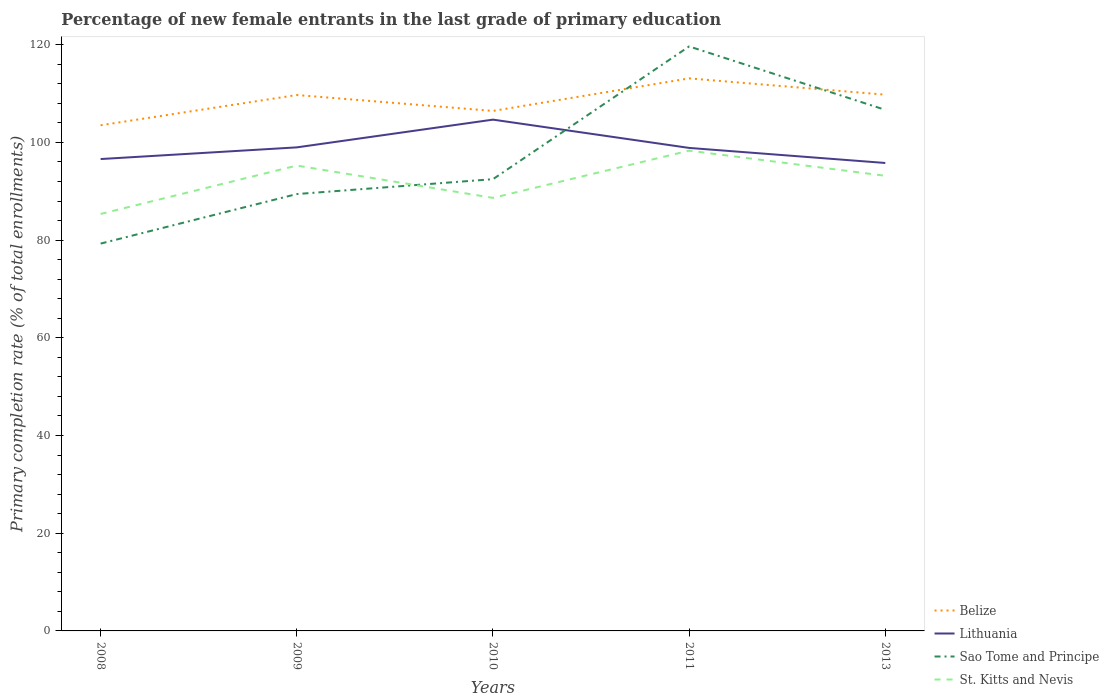How many different coloured lines are there?
Ensure brevity in your answer.  4. Does the line corresponding to Belize intersect with the line corresponding to St. Kitts and Nevis?
Provide a short and direct response. No. Across all years, what is the maximum percentage of new female entrants in Sao Tome and Principe?
Your answer should be very brief. 79.3. In which year was the percentage of new female entrants in Lithuania maximum?
Provide a short and direct response. 2013. What is the total percentage of new female entrants in Lithuania in the graph?
Your answer should be very brief. -2.39. What is the difference between the highest and the second highest percentage of new female entrants in Belize?
Your answer should be compact. 9.6. Is the percentage of new female entrants in Lithuania strictly greater than the percentage of new female entrants in Sao Tome and Principe over the years?
Your answer should be compact. No. How many lines are there?
Give a very brief answer. 4. What is the difference between two consecutive major ticks on the Y-axis?
Keep it short and to the point. 20. Are the values on the major ticks of Y-axis written in scientific E-notation?
Ensure brevity in your answer.  No. Does the graph contain any zero values?
Keep it short and to the point. No. Does the graph contain grids?
Ensure brevity in your answer.  No. Where does the legend appear in the graph?
Offer a terse response. Bottom right. How are the legend labels stacked?
Ensure brevity in your answer.  Vertical. What is the title of the graph?
Provide a succinct answer. Percentage of new female entrants in the last grade of primary education. What is the label or title of the X-axis?
Provide a short and direct response. Years. What is the label or title of the Y-axis?
Your answer should be very brief. Primary completion rate (% of total enrollments). What is the Primary completion rate (% of total enrollments) in Belize in 2008?
Offer a very short reply. 103.52. What is the Primary completion rate (% of total enrollments) of Lithuania in 2008?
Your answer should be very brief. 96.6. What is the Primary completion rate (% of total enrollments) of Sao Tome and Principe in 2008?
Make the answer very short. 79.3. What is the Primary completion rate (% of total enrollments) of St. Kitts and Nevis in 2008?
Offer a very short reply. 85.37. What is the Primary completion rate (% of total enrollments) in Belize in 2009?
Offer a terse response. 109.71. What is the Primary completion rate (% of total enrollments) of Lithuania in 2009?
Make the answer very short. 98.99. What is the Primary completion rate (% of total enrollments) of Sao Tome and Principe in 2009?
Your response must be concise. 89.44. What is the Primary completion rate (% of total enrollments) in St. Kitts and Nevis in 2009?
Offer a terse response. 95.27. What is the Primary completion rate (% of total enrollments) in Belize in 2010?
Provide a short and direct response. 106.45. What is the Primary completion rate (% of total enrollments) of Lithuania in 2010?
Your response must be concise. 104.67. What is the Primary completion rate (% of total enrollments) of Sao Tome and Principe in 2010?
Keep it short and to the point. 92.48. What is the Primary completion rate (% of total enrollments) of St. Kitts and Nevis in 2010?
Your answer should be very brief. 88.66. What is the Primary completion rate (% of total enrollments) of Belize in 2011?
Keep it short and to the point. 113.12. What is the Primary completion rate (% of total enrollments) in Lithuania in 2011?
Make the answer very short. 98.88. What is the Primary completion rate (% of total enrollments) in Sao Tome and Principe in 2011?
Give a very brief answer. 119.66. What is the Primary completion rate (% of total enrollments) of St. Kitts and Nevis in 2011?
Your response must be concise. 98.32. What is the Primary completion rate (% of total enrollments) of Belize in 2013?
Offer a very short reply. 109.78. What is the Primary completion rate (% of total enrollments) in Lithuania in 2013?
Your answer should be compact. 95.8. What is the Primary completion rate (% of total enrollments) in Sao Tome and Principe in 2013?
Keep it short and to the point. 106.68. What is the Primary completion rate (% of total enrollments) of St. Kitts and Nevis in 2013?
Offer a very short reply. 93.18. Across all years, what is the maximum Primary completion rate (% of total enrollments) of Belize?
Offer a terse response. 113.12. Across all years, what is the maximum Primary completion rate (% of total enrollments) in Lithuania?
Ensure brevity in your answer.  104.67. Across all years, what is the maximum Primary completion rate (% of total enrollments) of Sao Tome and Principe?
Ensure brevity in your answer.  119.66. Across all years, what is the maximum Primary completion rate (% of total enrollments) in St. Kitts and Nevis?
Your answer should be very brief. 98.32. Across all years, what is the minimum Primary completion rate (% of total enrollments) of Belize?
Keep it short and to the point. 103.52. Across all years, what is the minimum Primary completion rate (% of total enrollments) in Lithuania?
Make the answer very short. 95.8. Across all years, what is the minimum Primary completion rate (% of total enrollments) of Sao Tome and Principe?
Your answer should be compact. 79.3. Across all years, what is the minimum Primary completion rate (% of total enrollments) in St. Kitts and Nevis?
Your answer should be compact. 85.37. What is the total Primary completion rate (% of total enrollments) in Belize in the graph?
Make the answer very short. 542.58. What is the total Primary completion rate (% of total enrollments) in Lithuania in the graph?
Your answer should be compact. 494.95. What is the total Primary completion rate (% of total enrollments) in Sao Tome and Principe in the graph?
Keep it short and to the point. 487.55. What is the total Primary completion rate (% of total enrollments) of St. Kitts and Nevis in the graph?
Offer a terse response. 460.79. What is the difference between the Primary completion rate (% of total enrollments) in Belize in 2008 and that in 2009?
Offer a terse response. -6.19. What is the difference between the Primary completion rate (% of total enrollments) of Lithuania in 2008 and that in 2009?
Your response must be concise. -2.39. What is the difference between the Primary completion rate (% of total enrollments) of Sao Tome and Principe in 2008 and that in 2009?
Keep it short and to the point. -10.14. What is the difference between the Primary completion rate (% of total enrollments) in St. Kitts and Nevis in 2008 and that in 2009?
Give a very brief answer. -9.9. What is the difference between the Primary completion rate (% of total enrollments) of Belize in 2008 and that in 2010?
Offer a very short reply. -2.93. What is the difference between the Primary completion rate (% of total enrollments) in Lithuania in 2008 and that in 2010?
Make the answer very short. -8.07. What is the difference between the Primary completion rate (% of total enrollments) of Sao Tome and Principe in 2008 and that in 2010?
Provide a short and direct response. -13.19. What is the difference between the Primary completion rate (% of total enrollments) of St. Kitts and Nevis in 2008 and that in 2010?
Provide a short and direct response. -3.29. What is the difference between the Primary completion rate (% of total enrollments) in Belize in 2008 and that in 2011?
Keep it short and to the point. -9.6. What is the difference between the Primary completion rate (% of total enrollments) in Lithuania in 2008 and that in 2011?
Ensure brevity in your answer.  -2.28. What is the difference between the Primary completion rate (% of total enrollments) in Sao Tome and Principe in 2008 and that in 2011?
Your response must be concise. -40.36. What is the difference between the Primary completion rate (% of total enrollments) of St. Kitts and Nevis in 2008 and that in 2011?
Keep it short and to the point. -12.96. What is the difference between the Primary completion rate (% of total enrollments) in Belize in 2008 and that in 2013?
Ensure brevity in your answer.  -6.26. What is the difference between the Primary completion rate (% of total enrollments) of Lithuania in 2008 and that in 2013?
Your answer should be compact. 0.8. What is the difference between the Primary completion rate (% of total enrollments) of Sao Tome and Principe in 2008 and that in 2013?
Make the answer very short. -27.38. What is the difference between the Primary completion rate (% of total enrollments) of St. Kitts and Nevis in 2008 and that in 2013?
Make the answer very short. -7.81. What is the difference between the Primary completion rate (% of total enrollments) in Belize in 2009 and that in 2010?
Ensure brevity in your answer.  3.26. What is the difference between the Primary completion rate (% of total enrollments) of Lithuania in 2009 and that in 2010?
Your answer should be compact. -5.68. What is the difference between the Primary completion rate (% of total enrollments) in Sao Tome and Principe in 2009 and that in 2010?
Your response must be concise. -3.05. What is the difference between the Primary completion rate (% of total enrollments) of St. Kitts and Nevis in 2009 and that in 2010?
Offer a terse response. 6.61. What is the difference between the Primary completion rate (% of total enrollments) in Belize in 2009 and that in 2011?
Make the answer very short. -3.4. What is the difference between the Primary completion rate (% of total enrollments) in Lithuania in 2009 and that in 2011?
Provide a short and direct response. 0.11. What is the difference between the Primary completion rate (% of total enrollments) of Sao Tome and Principe in 2009 and that in 2011?
Your answer should be very brief. -30.22. What is the difference between the Primary completion rate (% of total enrollments) in St. Kitts and Nevis in 2009 and that in 2011?
Your answer should be very brief. -3.05. What is the difference between the Primary completion rate (% of total enrollments) of Belize in 2009 and that in 2013?
Your response must be concise. -0.07. What is the difference between the Primary completion rate (% of total enrollments) in Lithuania in 2009 and that in 2013?
Provide a short and direct response. 3.2. What is the difference between the Primary completion rate (% of total enrollments) in Sao Tome and Principe in 2009 and that in 2013?
Make the answer very short. -17.24. What is the difference between the Primary completion rate (% of total enrollments) in St. Kitts and Nevis in 2009 and that in 2013?
Offer a very short reply. 2.09. What is the difference between the Primary completion rate (% of total enrollments) of Belize in 2010 and that in 2011?
Your response must be concise. -6.66. What is the difference between the Primary completion rate (% of total enrollments) of Lithuania in 2010 and that in 2011?
Keep it short and to the point. 5.79. What is the difference between the Primary completion rate (% of total enrollments) in Sao Tome and Principe in 2010 and that in 2011?
Offer a terse response. -27.18. What is the difference between the Primary completion rate (% of total enrollments) of St. Kitts and Nevis in 2010 and that in 2011?
Provide a short and direct response. -9.67. What is the difference between the Primary completion rate (% of total enrollments) of Belize in 2010 and that in 2013?
Your answer should be very brief. -3.33. What is the difference between the Primary completion rate (% of total enrollments) in Lithuania in 2010 and that in 2013?
Ensure brevity in your answer.  8.87. What is the difference between the Primary completion rate (% of total enrollments) in Sao Tome and Principe in 2010 and that in 2013?
Ensure brevity in your answer.  -14.19. What is the difference between the Primary completion rate (% of total enrollments) in St. Kitts and Nevis in 2010 and that in 2013?
Offer a very short reply. -4.52. What is the difference between the Primary completion rate (% of total enrollments) of Belize in 2011 and that in 2013?
Offer a very short reply. 3.34. What is the difference between the Primary completion rate (% of total enrollments) in Lithuania in 2011 and that in 2013?
Offer a very short reply. 3.08. What is the difference between the Primary completion rate (% of total enrollments) in Sao Tome and Principe in 2011 and that in 2013?
Keep it short and to the point. 12.98. What is the difference between the Primary completion rate (% of total enrollments) of St. Kitts and Nevis in 2011 and that in 2013?
Ensure brevity in your answer.  5.15. What is the difference between the Primary completion rate (% of total enrollments) of Belize in 2008 and the Primary completion rate (% of total enrollments) of Lithuania in 2009?
Make the answer very short. 4.53. What is the difference between the Primary completion rate (% of total enrollments) in Belize in 2008 and the Primary completion rate (% of total enrollments) in Sao Tome and Principe in 2009?
Provide a short and direct response. 14.09. What is the difference between the Primary completion rate (% of total enrollments) in Belize in 2008 and the Primary completion rate (% of total enrollments) in St. Kitts and Nevis in 2009?
Your answer should be very brief. 8.25. What is the difference between the Primary completion rate (% of total enrollments) of Lithuania in 2008 and the Primary completion rate (% of total enrollments) of Sao Tome and Principe in 2009?
Provide a short and direct response. 7.17. What is the difference between the Primary completion rate (% of total enrollments) in Lithuania in 2008 and the Primary completion rate (% of total enrollments) in St. Kitts and Nevis in 2009?
Keep it short and to the point. 1.33. What is the difference between the Primary completion rate (% of total enrollments) of Sao Tome and Principe in 2008 and the Primary completion rate (% of total enrollments) of St. Kitts and Nevis in 2009?
Your response must be concise. -15.97. What is the difference between the Primary completion rate (% of total enrollments) of Belize in 2008 and the Primary completion rate (% of total enrollments) of Lithuania in 2010?
Offer a terse response. -1.15. What is the difference between the Primary completion rate (% of total enrollments) of Belize in 2008 and the Primary completion rate (% of total enrollments) of Sao Tome and Principe in 2010?
Your answer should be very brief. 11.04. What is the difference between the Primary completion rate (% of total enrollments) of Belize in 2008 and the Primary completion rate (% of total enrollments) of St. Kitts and Nevis in 2010?
Your answer should be compact. 14.87. What is the difference between the Primary completion rate (% of total enrollments) of Lithuania in 2008 and the Primary completion rate (% of total enrollments) of Sao Tome and Principe in 2010?
Offer a terse response. 4.12. What is the difference between the Primary completion rate (% of total enrollments) in Lithuania in 2008 and the Primary completion rate (% of total enrollments) in St. Kitts and Nevis in 2010?
Offer a very short reply. 7.95. What is the difference between the Primary completion rate (% of total enrollments) in Sao Tome and Principe in 2008 and the Primary completion rate (% of total enrollments) in St. Kitts and Nevis in 2010?
Ensure brevity in your answer.  -9.36. What is the difference between the Primary completion rate (% of total enrollments) of Belize in 2008 and the Primary completion rate (% of total enrollments) of Lithuania in 2011?
Keep it short and to the point. 4.64. What is the difference between the Primary completion rate (% of total enrollments) in Belize in 2008 and the Primary completion rate (% of total enrollments) in Sao Tome and Principe in 2011?
Provide a succinct answer. -16.14. What is the difference between the Primary completion rate (% of total enrollments) in Belize in 2008 and the Primary completion rate (% of total enrollments) in St. Kitts and Nevis in 2011?
Offer a terse response. 5.2. What is the difference between the Primary completion rate (% of total enrollments) in Lithuania in 2008 and the Primary completion rate (% of total enrollments) in Sao Tome and Principe in 2011?
Give a very brief answer. -23.05. What is the difference between the Primary completion rate (% of total enrollments) of Lithuania in 2008 and the Primary completion rate (% of total enrollments) of St. Kitts and Nevis in 2011?
Your answer should be compact. -1.72. What is the difference between the Primary completion rate (% of total enrollments) in Sao Tome and Principe in 2008 and the Primary completion rate (% of total enrollments) in St. Kitts and Nevis in 2011?
Provide a succinct answer. -19.03. What is the difference between the Primary completion rate (% of total enrollments) in Belize in 2008 and the Primary completion rate (% of total enrollments) in Lithuania in 2013?
Your answer should be very brief. 7.72. What is the difference between the Primary completion rate (% of total enrollments) of Belize in 2008 and the Primary completion rate (% of total enrollments) of Sao Tome and Principe in 2013?
Provide a short and direct response. -3.15. What is the difference between the Primary completion rate (% of total enrollments) of Belize in 2008 and the Primary completion rate (% of total enrollments) of St. Kitts and Nevis in 2013?
Your answer should be compact. 10.34. What is the difference between the Primary completion rate (% of total enrollments) of Lithuania in 2008 and the Primary completion rate (% of total enrollments) of Sao Tome and Principe in 2013?
Your response must be concise. -10.07. What is the difference between the Primary completion rate (% of total enrollments) of Lithuania in 2008 and the Primary completion rate (% of total enrollments) of St. Kitts and Nevis in 2013?
Keep it short and to the point. 3.43. What is the difference between the Primary completion rate (% of total enrollments) in Sao Tome and Principe in 2008 and the Primary completion rate (% of total enrollments) in St. Kitts and Nevis in 2013?
Keep it short and to the point. -13.88. What is the difference between the Primary completion rate (% of total enrollments) in Belize in 2009 and the Primary completion rate (% of total enrollments) in Lithuania in 2010?
Make the answer very short. 5.04. What is the difference between the Primary completion rate (% of total enrollments) in Belize in 2009 and the Primary completion rate (% of total enrollments) in Sao Tome and Principe in 2010?
Provide a succinct answer. 17.23. What is the difference between the Primary completion rate (% of total enrollments) in Belize in 2009 and the Primary completion rate (% of total enrollments) in St. Kitts and Nevis in 2010?
Provide a short and direct response. 21.06. What is the difference between the Primary completion rate (% of total enrollments) of Lithuania in 2009 and the Primary completion rate (% of total enrollments) of Sao Tome and Principe in 2010?
Your answer should be very brief. 6.51. What is the difference between the Primary completion rate (% of total enrollments) in Lithuania in 2009 and the Primary completion rate (% of total enrollments) in St. Kitts and Nevis in 2010?
Your response must be concise. 10.34. What is the difference between the Primary completion rate (% of total enrollments) of Sao Tome and Principe in 2009 and the Primary completion rate (% of total enrollments) of St. Kitts and Nevis in 2010?
Your answer should be compact. 0.78. What is the difference between the Primary completion rate (% of total enrollments) of Belize in 2009 and the Primary completion rate (% of total enrollments) of Lithuania in 2011?
Your answer should be very brief. 10.83. What is the difference between the Primary completion rate (% of total enrollments) in Belize in 2009 and the Primary completion rate (% of total enrollments) in Sao Tome and Principe in 2011?
Your answer should be compact. -9.94. What is the difference between the Primary completion rate (% of total enrollments) of Belize in 2009 and the Primary completion rate (% of total enrollments) of St. Kitts and Nevis in 2011?
Give a very brief answer. 11.39. What is the difference between the Primary completion rate (% of total enrollments) in Lithuania in 2009 and the Primary completion rate (% of total enrollments) in Sao Tome and Principe in 2011?
Your answer should be very brief. -20.66. What is the difference between the Primary completion rate (% of total enrollments) of Lithuania in 2009 and the Primary completion rate (% of total enrollments) of St. Kitts and Nevis in 2011?
Your answer should be very brief. 0.67. What is the difference between the Primary completion rate (% of total enrollments) in Sao Tome and Principe in 2009 and the Primary completion rate (% of total enrollments) in St. Kitts and Nevis in 2011?
Offer a terse response. -8.89. What is the difference between the Primary completion rate (% of total enrollments) of Belize in 2009 and the Primary completion rate (% of total enrollments) of Lithuania in 2013?
Keep it short and to the point. 13.91. What is the difference between the Primary completion rate (% of total enrollments) in Belize in 2009 and the Primary completion rate (% of total enrollments) in Sao Tome and Principe in 2013?
Provide a short and direct response. 3.04. What is the difference between the Primary completion rate (% of total enrollments) of Belize in 2009 and the Primary completion rate (% of total enrollments) of St. Kitts and Nevis in 2013?
Keep it short and to the point. 16.54. What is the difference between the Primary completion rate (% of total enrollments) in Lithuania in 2009 and the Primary completion rate (% of total enrollments) in Sao Tome and Principe in 2013?
Offer a very short reply. -7.68. What is the difference between the Primary completion rate (% of total enrollments) of Lithuania in 2009 and the Primary completion rate (% of total enrollments) of St. Kitts and Nevis in 2013?
Provide a succinct answer. 5.82. What is the difference between the Primary completion rate (% of total enrollments) of Sao Tome and Principe in 2009 and the Primary completion rate (% of total enrollments) of St. Kitts and Nevis in 2013?
Offer a terse response. -3.74. What is the difference between the Primary completion rate (% of total enrollments) of Belize in 2010 and the Primary completion rate (% of total enrollments) of Lithuania in 2011?
Give a very brief answer. 7.57. What is the difference between the Primary completion rate (% of total enrollments) of Belize in 2010 and the Primary completion rate (% of total enrollments) of Sao Tome and Principe in 2011?
Make the answer very short. -13.2. What is the difference between the Primary completion rate (% of total enrollments) in Belize in 2010 and the Primary completion rate (% of total enrollments) in St. Kitts and Nevis in 2011?
Provide a short and direct response. 8.13. What is the difference between the Primary completion rate (% of total enrollments) in Lithuania in 2010 and the Primary completion rate (% of total enrollments) in Sao Tome and Principe in 2011?
Offer a very short reply. -14.98. What is the difference between the Primary completion rate (% of total enrollments) of Lithuania in 2010 and the Primary completion rate (% of total enrollments) of St. Kitts and Nevis in 2011?
Ensure brevity in your answer.  6.35. What is the difference between the Primary completion rate (% of total enrollments) of Sao Tome and Principe in 2010 and the Primary completion rate (% of total enrollments) of St. Kitts and Nevis in 2011?
Ensure brevity in your answer.  -5.84. What is the difference between the Primary completion rate (% of total enrollments) in Belize in 2010 and the Primary completion rate (% of total enrollments) in Lithuania in 2013?
Keep it short and to the point. 10.65. What is the difference between the Primary completion rate (% of total enrollments) of Belize in 2010 and the Primary completion rate (% of total enrollments) of Sao Tome and Principe in 2013?
Give a very brief answer. -0.22. What is the difference between the Primary completion rate (% of total enrollments) in Belize in 2010 and the Primary completion rate (% of total enrollments) in St. Kitts and Nevis in 2013?
Provide a short and direct response. 13.28. What is the difference between the Primary completion rate (% of total enrollments) in Lithuania in 2010 and the Primary completion rate (% of total enrollments) in Sao Tome and Principe in 2013?
Keep it short and to the point. -2. What is the difference between the Primary completion rate (% of total enrollments) in Lithuania in 2010 and the Primary completion rate (% of total enrollments) in St. Kitts and Nevis in 2013?
Provide a short and direct response. 11.5. What is the difference between the Primary completion rate (% of total enrollments) in Sao Tome and Principe in 2010 and the Primary completion rate (% of total enrollments) in St. Kitts and Nevis in 2013?
Your answer should be compact. -0.69. What is the difference between the Primary completion rate (% of total enrollments) in Belize in 2011 and the Primary completion rate (% of total enrollments) in Lithuania in 2013?
Your answer should be very brief. 17.32. What is the difference between the Primary completion rate (% of total enrollments) of Belize in 2011 and the Primary completion rate (% of total enrollments) of Sao Tome and Principe in 2013?
Your answer should be very brief. 6.44. What is the difference between the Primary completion rate (% of total enrollments) in Belize in 2011 and the Primary completion rate (% of total enrollments) in St. Kitts and Nevis in 2013?
Make the answer very short. 19.94. What is the difference between the Primary completion rate (% of total enrollments) of Lithuania in 2011 and the Primary completion rate (% of total enrollments) of Sao Tome and Principe in 2013?
Offer a terse response. -7.79. What is the difference between the Primary completion rate (% of total enrollments) of Lithuania in 2011 and the Primary completion rate (% of total enrollments) of St. Kitts and Nevis in 2013?
Your answer should be very brief. 5.71. What is the difference between the Primary completion rate (% of total enrollments) in Sao Tome and Principe in 2011 and the Primary completion rate (% of total enrollments) in St. Kitts and Nevis in 2013?
Provide a succinct answer. 26.48. What is the average Primary completion rate (% of total enrollments) in Belize per year?
Your answer should be compact. 108.52. What is the average Primary completion rate (% of total enrollments) in Lithuania per year?
Your answer should be very brief. 98.99. What is the average Primary completion rate (% of total enrollments) of Sao Tome and Principe per year?
Offer a very short reply. 97.51. What is the average Primary completion rate (% of total enrollments) in St. Kitts and Nevis per year?
Provide a succinct answer. 92.16. In the year 2008, what is the difference between the Primary completion rate (% of total enrollments) in Belize and Primary completion rate (% of total enrollments) in Lithuania?
Offer a terse response. 6.92. In the year 2008, what is the difference between the Primary completion rate (% of total enrollments) in Belize and Primary completion rate (% of total enrollments) in Sao Tome and Principe?
Provide a short and direct response. 24.23. In the year 2008, what is the difference between the Primary completion rate (% of total enrollments) in Belize and Primary completion rate (% of total enrollments) in St. Kitts and Nevis?
Your answer should be compact. 18.16. In the year 2008, what is the difference between the Primary completion rate (% of total enrollments) of Lithuania and Primary completion rate (% of total enrollments) of Sao Tome and Principe?
Keep it short and to the point. 17.31. In the year 2008, what is the difference between the Primary completion rate (% of total enrollments) in Lithuania and Primary completion rate (% of total enrollments) in St. Kitts and Nevis?
Your response must be concise. 11.24. In the year 2008, what is the difference between the Primary completion rate (% of total enrollments) in Sao Tome and Principe and Primary completion rate (% of total enrollments) in St. Kitts and Nevis?
Your answer should be compact. -6.07. In the year 2009, what is the difference between the Primary completion rate (% of total enrollments) in Belize and Primary completion rate (% of total enrollments) in Lithuania?
Make the answer very short. 10.72. In the year 2009, what is the difference between the Primary completion rate (% of total enrollments) of Belize and Primary completion rate (% of total enrollments) of Sao Tome and Principe?
Your response must be concise. 20.28. In the year 2009, what is the difference between the Primary completion rate (% of total enrollments) in Belize and Primary completion rate (% of total enrollments) in St. Kitts and Nevis?
Your answer should be very brief. 14.44. In the year 2009, what is the difference between the Primary completion rate (% of total enrollments) in Lithuania and Primary completion rate (% of total enrollments) in Sao Tome and Principe?
Offer a terse response. 9.56. In the year 2009, what is the difference between the Primary completion rate (% of total enrollments) of Lithuania and Primary completion rate (% of total enrollments) of St. Kitts and Nevis?
Provide a short and direct response. 3.73. In the year 2009, what is the difference between the Primary completion rate (% of total enrollments) of Sao Tome and Principe and Primary completion rate (% of total enrollments) of St. Kitts and Nevis?
Your answer should be very brief. -5.83. In the year 2010, what is the difference between the Primary completion rate (% of total enrollments) of Belize and Primary completion rate (% of total enrollments) of Lithuania?
Keep it short and to the point. 1.78. In the year 2010, what is the difference between the Primary completion rate (% of total enrollments) of Belize and Primary completion rate (% of total enrollments) of Sao Tome and Principe?
Give a very brief answer. 13.97. In the year 2010, what is the difference between the Primary completion rate (% of total enrollments) of Belize and Primary completion rate (% of total enrollments) of St. Kitts and Nevis?
Provide a short and direct response. 17.8. In the year 2010, what is the difference between the Primary completion rate (% of total enrollments) of Lithuania and Primary completion rate (% of total enrollments) of Sao Tome and Principe?
Your answer should be very brief. 12.19. In the year 2010, what is the difference between the Primary completion rate (% of total enrollments) of Lithuania and Primary completion rate (% of total enrollments) of St. Kitts and Nevis?
Make the answer very short. 16.02. In the year 2010, what is the difference between the Primary completion rate (% of total enrollments) in Sao Tome and Principe and Primary completion rate (% of total enrollments) in St. Kitts and Nevis?
Ensure brevity in your answer.  3.83. In the year 2011, what is the difference between the Primary completion rate (% of total enrollments) in Belize and Primary completion rate (% of total enrollments) in Lithuania?
Your answer should be compact. 14.23. In the year 2011, what is the difference between the Primary completion rate (% of total enrollments) of Belize and Primary completion rate (% of total enrollments) of Sao Tome and Principe?
Provide a succinct answer. -6.54. In the year 2011, what is the difference between the Primary completion rate (% of total enrollments) in Belize and Primary completion rate (% of total enrollments) in St. Kitts and Nevis?
Provide a succinct answer. 14.79. In the year 2011, what is the difference between the Primary completion rate (% of total enrollments) of Lithuania and Primary completion rate (% of total enrollments) of Sao Tome and Principe?
Offer a very short reply. -20.78. In the year 2011, what is the difference between the Primary completion rate (% of total enrollments) in Lithuania and Primary completion rate (% of total enrollments) in St. Kitts and Nevis?
Provide a short and direct response. 0.56. In the year 2011, what is the difference between the Primary completion rate (% of total enrollments) of Sao Tome and Principe and Primary completion rate (% of total enrollments) of St. Kitts and Nevis?
Give a very brief answer. 21.33. In the year 2013, what is the difference between the Primary completion rate (% of total enrollments) in Belize and Primary completion rate (% of total enrollments) in Lithuania?
Your answer should be compact. 13.98. In the year 2013, what is the difference between the Primary completion rate (% of total enrollments) of Belize and Primary completion rate (% of total enrollments) of Sao Tome and Principe?
Make the answer very short. 3.1. In the year 2013, what is the difference between the Primary completion rate (% of total enrollments) in Belize and Primary completion rate (% of total enrollments) in St. Kitts and Nevis?
Your answer should be very brief. 16.6. In the year 2013, what is the difference between the Primary completion rate (% of total enrollments) of Lithuania and Primary completion rate (% of total enrollments) of Sao Tome and Principe?
Your answer should be compact. -10.88. In the year 2013, what is the difference between the Primary completion rate (% of total enrollments) in Lithuania and Primary completion rate (% of total enrollments) in St. Kitts and Nevis?
Provide a short and direct response. 2.62. In the year 2013, what is the difference between the Primary completion rate (% of total enrollments) in Sao Tome and Principe and Primary completion rate (% of total enrollments) in St. Kitts and Nevis?
Provide a succinct answer. 13.5. What is the ratio of the Primary completion rate (% of total enrollments) of Belize in 2008 to that in 2009?
Your response must be concise. 0.94. What is the ratio of the Primary completion rate (% of total enrollments) in Lithuania in 2008 to that in 2009?
Provide a succinct answer. 0.98. What is the ratio of the Primary completion rate (% of total enrollments) of Sao Tome and Principe in 2008 to that in 2009?
Your answer should be compact. 0.89. What is the ratio of the Primary completion rate (% of total enrollments) in St. Kitts and Nevis in 2008 to that in 2009?
Your answer should be compact. 0.9. What is the ratio of the Primary completion rate (% of total enrollments) of Belize in 2008 to that in 2010?
Offer a very short reply. 0.97. What is the ratio of the Primary completion rate (% of total enrollments) in Lithuania in 2008 to that in 2010?
Your answer should be very brief. 0.92. What is the ratio of the Primary completion rate (% of total enrollments) of Sao Tome and Principe in 2008 to that in 2010?
Offer a terse response. 0.86. What is the ratio of the Primary completion rate (% of total enrollments) in St. Kitts and Nevis in 2008 to that in 2010?
Give a very brief answer. 0.96. What is the ratio of the Primary completion rate (% of total enrollments) in Belize in 2008 to that in 2011?
Provide a short and direct response. 0.92. What is the ratio of the Primary completion rate (% of total enrollments) in Lithuania in 2008 to that in 2011?
Ensure brevity in your answer.  0.98. What is the ratio of the Primary completion rate (% of total enrollments) in Sao Tome and Principe in 2008 to that in 2011?
Provide a short and direct response. 0.66. What is the ratio of the Primary completion rate (% of total enrollments) of St. Kitts and Nevis in 2008 to that in 2011?
Your answer should be very brief. 0.87. What is the ratio of the Primary completion rate (% of total enrollments) in Belize in 2008 to that in 2013?
Your response must be concise. 0.94. What is the ratio of the Primary completion rate (% of total enrollments) in Lithuania in 2008 to that in 2013?
Your response must be concise. 1.01. What is the ratio of the Primary completion rate (% of total enrollments) in Sao Tome and Principe in 2008 to that in 2013?
Provide a short and direct response. 0.74. What is the ratio of the Primary completion rate (% of total enrollments) of St. Kitts and Nevis in 2008 to that in 2013?
Provide a succinct answer. 0.92. What is the ratio of the Primary completion rate (% of total enrollments) in Belize in 2009 to that in 2010?
Make the answer very short. 1.03. What is the ratio of the Primary completion rate (% of total enrollments) of Lithuania in 2009 to that in 2010?
Your answer should be very brief. 0.95. What is the ratio of the Primary completion rate (% of total enrollments) of Sao Tome and Principe in 2009 to that in 2010?
Your answer should be compact. 0.97. What is the ratio of the Primary completion rate (% of total enrollments) of St. Kitts and Nevis in 2009 to that in 2010?
Ensure brevity in your answer.  1.07. What is the ratio of the Primary completion rate (% of total enrollments) of Belize in 2009 to that in 2011?
Give a very brief answer. 0.97. What is the ratio of the Primary completion rate (% of total enrollments) in Sao Tome and Principe in 2009 to that in 2011?
Provide a short and direct response. 0.75. What is the ratio of the Primary completion rate (% of total enrollments) of St. Kitts and Nevis in 2009 to that in 2011?
Give a very brief answer. 0.97. What is the ratio of the Primary completion rate (% of total enrollments) in Lithuania in 2009 to that in 2013?
Offer a very short reply. 1.03. What is the ratio of the Primary completion rate (% of total enrollments) in Sao Tome and Principe in 2009 to that in 2013?
Ensure brevity in your answer.  0.84. What is the ratio of the Primary completion rate (% of total enrollments) in St. Kitts and Nevis in 2009 to that in 2013?
Your answer should be very brief. 1.02. What is the ratio of the Primary completion rate (% of total enrollments) in Belize in 2010 to that in 2011?
Your answer should be compact. 0.94. What is the ratio of the Primary completion rate (% of total enrollments) of Lithuania in 2010 to that in 2011?
Provide a short and direct response. 1.06. What is the ratio of the Primary completion rate (% of total enrollments) of Sao Tome and Principe in 2010 to that in 2011?
Ensure brevity in your answer.  0.77. What is the ratio of the Primary completion rate (% of total enrollments) of St. Kitts and Nevis in 2010 to that in 2011?
Your answer should be very brief. 0.9. What is the ratio of the Primary completion rate (% of total enrollments) of Belize in 2010 to that in 2013?
Provide a short and direct response. 0.97. What is the ratio of the Primary completion rate (% of total enrollments) of Lithuania in 2010 to that in 2013?
Your answer should be very brief. 1.09. What is the ratio of the Primary completion rate (% of total enrollments) in Sao Tome and Principe in 2010 to that in 2013?
Offer a terse response. 0.87. What is the ratio of the Primary completion rate (% of total enrollments) in St. Kitts and Nevis in 2010 to that in 2013?
Make the answer very short. 0.95. What is the ratio of the Primary completion rate (% of total enrollments) in Belize in 2011 to that in 2013?
Your answer should be very brief. 1.03. What is the ratio of the Primary completion rate (% of total enrollments) of Lithuania in 2011 to that in 2013?
Provide a short and direct response. 1.03. What is the ratio of the Primary completion rate (% of total enrollments) in Sao Tome and Principe in 2011 to that in 2013?
Give a very brief answer. 1.12. What is the ratio of the Primary completion rate (% of total enrollments) of St. Kitts and Nevis in 2011 to that in 2013?
Make the answer very short. 1.06. What is the difference between the highest and the second highest Primary completion rate (% of total enrollments) in Belize?
Ensure brevity in your answer.  3.34. What is the difference between the highest and the second highest Primary completion rate (% of total enrollments) of Lithuania?
Your answer should be compact. 5.68. What is the difference between the highest and the second highest Primary completion rate (% of total enrollments) in Sao Tome and Principe?
Make the answer very short. 12.98. What is the difference between the highest and the second highest Primary completion rate (% of total enrollments) of St. Kitts and Nevis?
Keep it short and to the point. 3.05. What is the difference between the highest and the lowest Primary completion rate (% of total enrollments) of Belize?
Give a very brief answer. 9.6. What is the difference between the highest and the lowest Primary completion rate (% of total enrollments) of Lithuania?
Your answer should be very brief. 8.87. What is the difference between the highest and the lowest Primary completion rate (% of total enrollments) in Sao Tome and Principe?
Ensure brevity in your answer.  40.36. What is the difference between the highest and the lowest Primary completion rate (% of total enrollments) of St. Kitts and Nevis?
Keep it short and to the point. 12.96. 